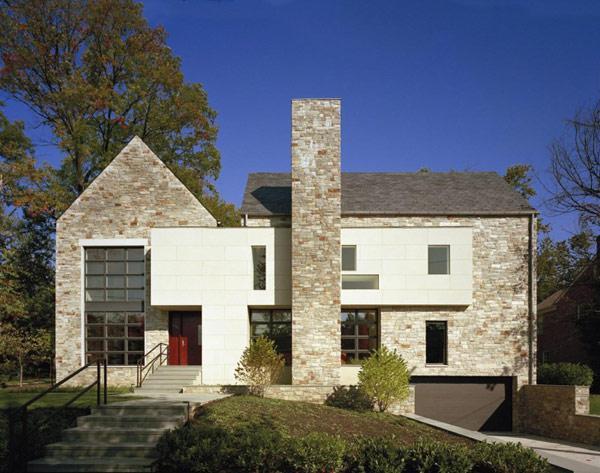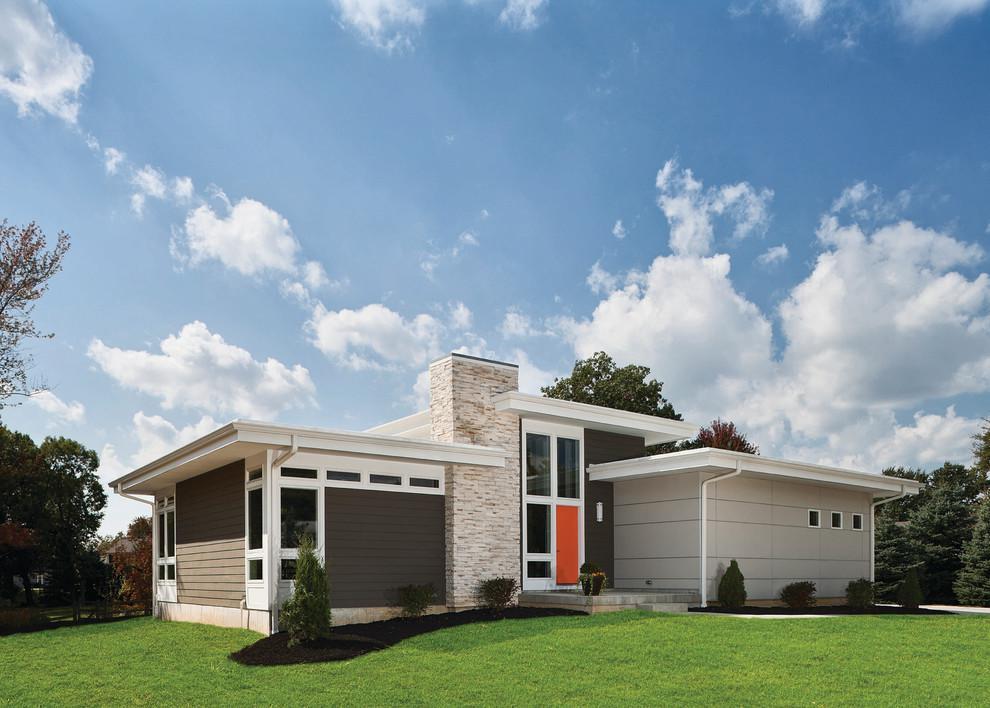The first image is the image on the left, the second image is the image on the right. Examine the images to the left and right. Is the description "A mid century modern house has a flat roof." accurate? Answer yes or no. Yes. The first image is the image on the left, the second image is the image on the right. Analyze the images presented: Is the assertion "One of the homes has a flat roof and the other has angular roof lines." valid? Answer yes or no. Yes. 